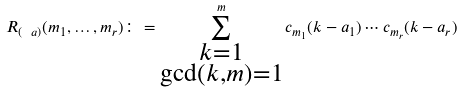<formula> <loc_0><loc_0><loc_500><loc_500>R _ { ( \ a ) } ( m _ { 1 } , \dots , m _ { r } ) \colon = \sum _ { \substack { k = 1 \\ \gcd ( k , m ) = 1 } } ^ { m } c _ { m _ { 1 } } ( k - a _ { 1 } ) \cdots c _ { m _ { r } } ( k - a _ { r } )</formula> 